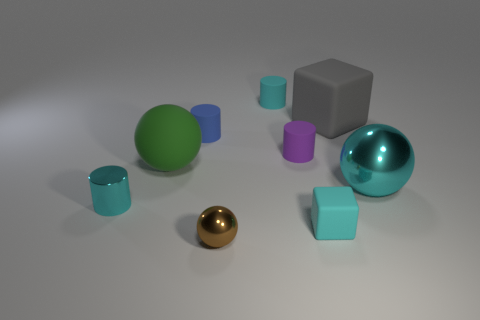Subtract all blue cylinders. How many cylinders are left? 3 Subtract all red cylinders. Subtract all purple spheres. How many cylinders are left? 4 Add 1 brown balls. How many objects exist? 10 Subtract all blocks. How many objects are left? 7 Add 6 big matte things. How many big matte things are left? 8 Add 2 gray metallic cylinders. How many gray metallic cylinders exist? 2 Subtract 1 cyan spheres. How many objects are left? 8 Subtract all small blue rubber blocks. Subtract all tiny cyan metallic things. How many objects are left? 8 